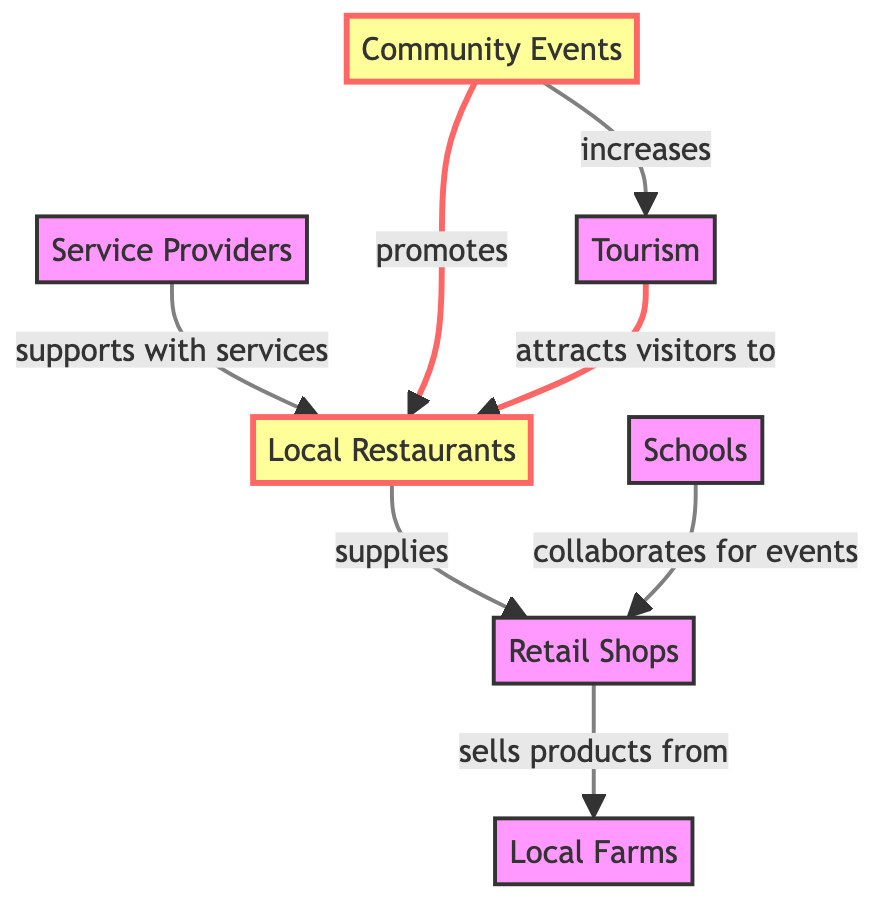What are the two main categories of local businesses connected in this diagram? The diagram features local restaurants and retail shops as two main nodes. They are distinct categories that engage in mutual relationships, exemplified by the supply link between them.
Answer: local restaurants, retail shops How many nodes are present in the diagram? By counting the unique identifiers designated for each node, we see that there are seven distinct categories of businesses represented: local restaurants, retail shops, local farms, service providers, community events, tourism, and schools.
Answer: 7 What type of relationship exists between local restaurants and retail shops? The diagram indicates that the local restaurants supply the retail shops, establishing a direct partnership where one entity provides goods to the other.
Answer: supplies Which sector promotes local restaurants? The community events sector is noted as promoting local restaurants, indicating an effort to market and support the dining options within the community.
Answer: community events What sector increases tourism according to this diagram? The connection from community events to tourism shows that events specifically help in enhancing visitor interest, thus increasing tourism within the area.
Answer: community events How do schools collaborate with retail shops? Retail shops and schools collaborate for events, suggesting that they work together to organize activities that may involve local products and engage the community.
Answer: collaborates for events Which sector directly supports local restaurants with services? The service providers are shown in the diagram as supporting local restaurants with essential services, enhancing their operational capabilities and contributing to their success.
Answer: service providers How many relationships are there in total in the diagram? By examining the outgoing connections from each of the nodes, the diagram reveals a total of six relationships established among the various sectors depicted.
Answer: 6 What effect do community events have on tourism? Community events have a direct positive effect on tourism, as indicated by the relationship shown in the diagram that states community events increase tourism within the area.
Answer: increases 